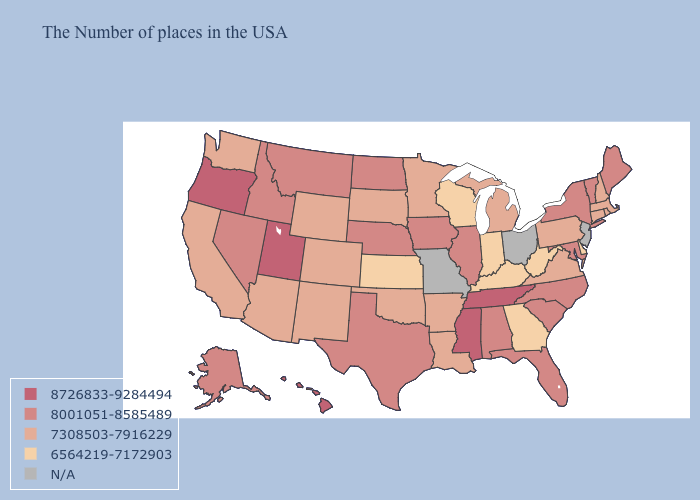Among the states that border Massachusetts , does Rhode Island have the highest value?
Concise answer only. No. Name the states that have a value in the range N/A?
Give a very brief answer. New Jersey, Ohio, Missouri. Which states have the highest value in the USA?
Quick response, please. Tennessee, Mississippi, Utah, Oregon, Hawaii. Name the states that have a value in the range 7308503-7916229?
Write a very short answer. Massachusetts, Rhode Island, New Hampshire, Connecticut, Pennsylvania, Virginia, Michigan, Louisiana, Arkansas, Minnesota, Oklahoma, South Dakota, Wyoming, Colorado, New Mexico, Arizona, California, Washington. Name the states that have a value in the range 7308503-7916229?
Write a very short answer. Massachusetts, Rhode Island, New Hampshire, Connecticut, Pennsylvania, Virginia, Michigan, Louisiana, Arkansas, Minnesota, Oklahoma, South Dakota, Wyoming, Colorado, New Mexico, Arizona, California, Washington. What is the lowest value in the West?
Quick response, please. 7308503-7916229. Among the states that border Vermont , which have the highest value?
Give a very brief answer. New York. What is the lowest value in states that border Nevada?
Quick response, please. 7308503-7916229. What is the value of Wyoming?
Give a very brief answer. 7308503-7916229. What is the value of Georgia?
Give a very brief answer. 6564219-7172903. Name the states that have a value in the range N/A?
Keep it brief. New Jersey, Ohio, Missouri. What is the value of Maine?
Give a very brief answer. 8001051-8585489. What is the value of Washington?
Give a very brief answer. 7308503-7916229. What is the highest value in the MidWest ?
Give a very brief answer. 8001051-8585489. 